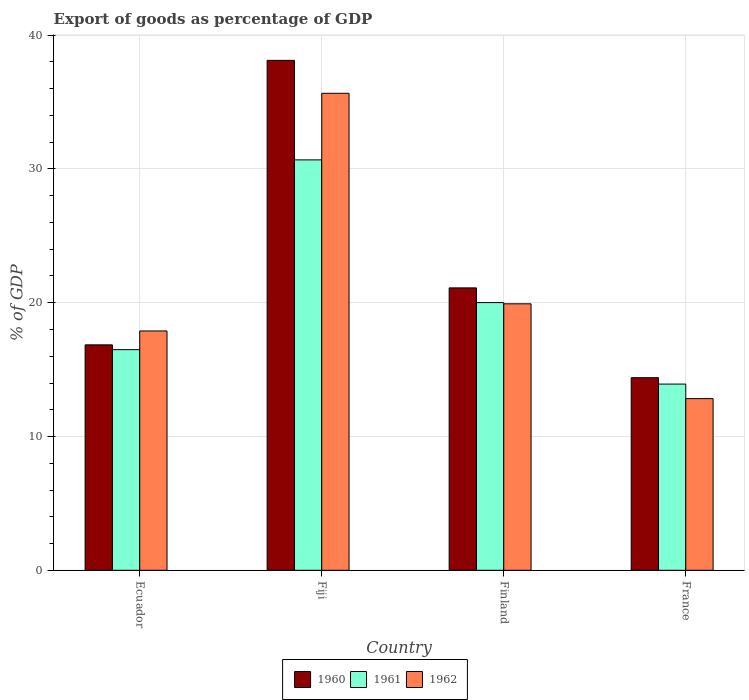How many groups of bars are there?
Offer a terse response. 4. Are the number of bars per tick equal to the number of legend labels?
Make the answer very short. Yes. Are the number of bars on each tick of the X-axis equal?
Your answer should be compact. Yes. How many bars are there on the 2nd tick from the left?
Provide a succinct answer. 3. How many bars are there on the 2nd tick from the right?
Your answer should be very brief. 3. What is the label of the 3rd group of bars from the left?
Offer a terse response. Finland. What is the export of goods as percentage of GDP in 1962 in France?
Your response must be concise. 12.83. Across all countries, what is the maximum export of goods as percentage of GDP in 1960?
Provide a short and direct response. 38.12. Across all countries, what is the minimum export of goods as percentage of GDP in 1962?
Provide a short and direct response. 12.83. In which country was the export of goods as percentage of GDP in 1962 maximum?
Your answer should be very brief. Fiji. What is the total export of goods as percentage of GDP in 1960 in the graph?
Provide a succinct answer. 90.47. What is the difference between the export of goods as percentage of GDP in 1962 in Fiji and that in Finland?
Offer a very short reply. 15.74. What is the difference between the export of goods as percentage of GDP in 1960 in Fiji and the export of goods as percentage of GDP in 1962 in Ecuador?
Ensure brevity in your answer.  20.23. What is the average export of goods as percentage of GDP in 1962 per country?
Keep it short and to the point. 21.57. What is the difference between the export of goods as percentage of GDP of/in 1960 and export of goods as percentage of GDP of/in 1962 in France?
Offer a very short reply. 1.56. In how many countries, is the export of goods as percentage of GDP in 1961 greater than 16 %?
Your response must be concise. 3. What is the ratio of the export of goods as percentage of GDP in 1961 in Fiji to that in Finland?
Make the answer very short. 1.53. Is the export of goods as percentage of GDP in 1960 in Ecuador less than that in Finland?
Give a very brief answer. Yes. Is the difference between the export of goods as percentage of GDP in 1960 in Ecuador and Fiji greater than the difference between the export of goods as percentage of GDP in 1962 in Ecuador and Fiji?
Provide a short and direct response. No. What is the difference between the highest and the second highest export of goods as percentage of GDP in 1961?
Your answer should be compact. -3.52. What is the difference between the highest and the lowest export of goods as percentage of GDP in 1961?
Provide a succinct answer. 16.76. What does the 2nd bar from the right in France represents?
Offer a terse response. 1961. Is it the case that in every country, the sum of the export of goods as percentage of GDP in 1960 and export of goods as percentage of GDP in 1961 is greater than the export of goods as percentage of GDP in 1962?
Offer a very short reply. Yes. Are all the bars in the graph horizontal?
Provide a succinct answer. No. How many countries are there in the graph?
Offer a terse response. 4. Does the graph contain grids?
Provide a succinct answer. Yes. Where does the legend appear in the graph?
Offer a very short reply. Bottom center. How many legend labels are there?
Provide a short and direct response. 3. What is the title of the graph?
Ensure brevity in your answer.  Export of goods as percentage of GDP. Does "1995" appear as one of the legend labels in the graph?
Keep it short and to the point. No. What is the label or title of the Y-axis?
Provide a succinct answer. % of GDP. What is the % of GDP in 1960 in Ecuador?
Offer a terse response. 16.85. What is the % of GDP of 1961 in Ecuador?
Give a very brief answer. 16.49. What is the % of GDP in 1962 in Ecuador?
Your answer should be compact. 17.89. What is the % of GDP in 1960 in Fiji?
Your answer should be compact. 38.12. What is the % of GDP of 1961 in Fiji?
Your answer should be compact. 30.68. What is the % of GDP in 1962 in Fiji?
Give a very brief answer. 35.66. What is the % of GDP of 1960 in Finland?
Give a very brief answer. 21.11. What is the % of GDP in 1961 in Finland?
Keep it short and to the point. 20.01. What is the % of GDP of 1962 in Finland?
Your answer should be compact. 19.92. What is the % of GDP of 1960 in France?
Your answer should be compact. 14.4. What is the % of GDP of 1961 in France?
Your answer should be very brief. 13.92. What is the % of GDP of 1962 in France?
Your answer should be compact. 12.83. Across all countries, what is the maximum % of GDP of 1960?
Provide a succinct answer. 38.12. Across all countries, what is the maximum % of GDP of 1961?
Ensure brevity in your answer.  30.68. Across all countries, what is the maximum % of GDP in 1962?
Keep it short and to the point. 35.66. Across all countries, what is the minimum % of GDP of 1960?
Make the answer very short. 14.4. Across all countries, what is the minimum % of GDP in 1961?
Your answer should be compact. 13.92. Across all countries, what is the minimum % of GDP in 1962?
Make the answer very short. 12.83. What is the total % of GDP in 1960 in the graph?
Offer a terse response. 90.47. What is the total % of GDP in 1961 in the graph?
Keep it short and to the point. 81.1. What is the total % of GDP in 1962 in the graph?
Your answer should be compact. 86.3. What is the difference between the % of GDP in 1960 in Ecuador and that in Fiji?
Offer a very short reply. -21.26. What is the difference between the % of GDP of 1961 in Ecuador and that in Fiji?
Offer a terse response. -14.18. What is the difference between the % of GDP in 1962 in Ecuador and that in Fiji?
Offer a very short reply. -17.77. What is the difference between the % of GDP in 1960 in Ecuador and that in Finland?
Give a very brief answer. -4.26. What is the difference between the % of GDP in 1961 in Ecuador and that in Finland?
Ensure brevity in your answer.  -3.52. What is the difference between the % of GDP in 1962 in Ecuador and that in Finland?
Your response must be concise. -2.03. What is the difference between the % of GDP of 1960 in Ecuador and that in France?
Ensure brevity in your answer.  2.46. What is the difference between the % of GDP of 1961 in Ecuador and that in France?
Keep it short and to the point. 2.57. What is the difference between the % of GDP in 1962 in Ecuador and that in France?
Your answer should be very brief. 5.06. What is the difference between the % of GDP of 1960 in Fiji and that in Finland?
Give a very brief answer. 17.01. What is the difference between the % of GDP of 1961 in Fiji and that in Finland?
Ensure brevity in your answer.  10.67. What is the difference between the % of GDP of 1962 in Fiji and that in Finland?
Keep it short and to the point. 15.74. What is the difference between the % of GDP of 1960 in Fiji and that in France?
Offer a very short reply. 23.72. What is the difference between the % of GDP in 1961 in Fiji and that in France?
Ensure brevity in your answer.  16.76. What is the difference between the % of GDP in 1962 in Fiji and that in France?
Your answer should be very brief. 22.82. What is the difference between the % of GDP of 1960 in Finland and that in France?
Offer a very short reply. 6.71. What is the difference between the % of GDP in 1961 in Finland and that in France?
Ensure brevity in your answer.  6.09. What is the difference between the % of GDP in 1962 in Finland and that in France?
Your answer should be compact. 7.09. What is the difference between the % of GDP in 1960 in Ecuador and the % of GDP in 1961 in Fiji?
Provide a short and direct response. -13.83. What is the difference between the % of GDP in 1960 in Ecuador and the % of GDP in 1962 in Fiji?
Provide a short and direct response. -18.8. What is the difference between the % of GDP of 1961 in Ecuador and the % of GDP of 1962 in Fiji?
Ensure brevity in your answer.  -19.16. What is the difference between the % of GDP of 1960 in Ecuador and the % of GDP of 1961 in Finland?
Offer a terse response. -3.16. What is the difference between the % of GDP in 1960 in Ecuador and the % of GDP in 1962 in Finland?
Give a very brief answer. -3.07. What is the difference between the % of GDP in 1961 in Ecuador and the % of GDP in 1962 in Finland?
Make the answer very short. -3.43. What is the difference between the % of GDP in 1960 in Ecuador and the % of GDP in 1961 in France?
Offer a terse response. 2.93. What is the difference between the % of GDP of 1960 in Ecuador and the % of GDP of 1962 in France?
Make the answer very short. 4.02. What is the difference between the % of GDP of 1961 in Ecuador and the % of GDP of 1962 in France?
Keep it short and to the point. 3.66. What is the difference between the % of GDP in 1960 in Fiji and the % of GDP in 1961 in Finland?
Keep it short and to the point. 18.11. What is the difference between the % of GDP in 1960 in Fiji and the % of GDP in 1962 in Finland?
Keep it short and to the point. 18.2. What is the difference between the % of GDP in 1961 in Fiji and the % of GDP in 1962 in Finland?
Offer a very short reply. 10.76. What is the difference between the % of GDP of 1960 in Fiji and the % of GDP of 1961 in France?
Provide a short and direct response. 24.2. What is the difference between the % of GDP in 1960 in Fiji and the % of GDP in 1962 in France?
Your answer should be very brief. 25.28. What is the difference between the % of GDP of 1961 in Fiji and the % of GDP of 1962 in France?
Provide a short and direct response. 17.85. What is the difference between the % of GDP of 1960 in Finland and the % of GDP of 1961 in France?
Give a very brief answer. 7.19. What is the difference between the % of GDP in 1960 in Finland and the % of GDP in 1962 in France?
Provide a succinct answer. 8.28. What is the difference between the % of GDP in 1961 in Finland and the % of GDP in 1962 in France?
Keep it short and to the point. 7.18. What is the average % of GDP of 1960 per country?
Your response must be concise. 22.62. What is the average % of GDP of 1961 per country?
Keep it short and to the point. 20.27. What is the average % of GDP in 1962 per country?
Keep it short and to the point. 21.57. What is the difference between the % of GDP of 1960 and % of GDP of 1961 in Ecuador?
Your answer should be compact. 0.36. What is the difference between the % of GDP of 1960 and % of GDP of 1962 in Ecuador?
Make the answer very short. -1.04. What is the difference between the % of GDP of 1961 and % of GDP of 1962 in Ecuador?
Offer a terse response. -1.4. What is the difference between the % of GDP in 1960 and % of GDP in 1961 in Fiji?
Give a very brief answer. 7.44. What is the difference between the % of GDP in 1960 and % of GDP in 1962 in Fiji?
Give a very brief answer. 2.46. What is the difference between the % of GDP in 1961 and % of GDP in 1962 in Fiji?
Provide a short and direct response. -4.98. What is the difference between the % of GDP in 1960 and % of GDP in 1961 in Finland?
Offer a terse response. 1.1. What is the difference between the % of GDP in 1960 and % of GDP in 1962 in Finland?
Keep it short and to the point. 1.19. What is the difference between the % of GDP of 1961 and % of GDP of 1962 in Finland?
Ensure brevity in your answer.  0.09. What is the difference between the % of GDP in 1960 and % of GDP in 1961 in France?
Offer a very short reply. 0.48. What is the difference between the % of GDP in 1960 and % of GDP in 1962 in France?
Offer a terse response. 1.56. What is the difference between the % of GDP of 1961 and % of GDP of 1962 in France?
Your answer should be very brief. 1.09. What is the ratio of the % of GDP of 1960 in Ecuador to that in Fiji?
Give a very brief answer. 0.44. What is the ratio of the % of GDP in 1961 in Ecuador to that in Fiji?
Give a very brief answer. 0.54. What is the ratio of the % of GDP of 1962 in Ecuador to that in Fiji?
Ensure brevity in your answer.  0.5. What is the ratio of the % of GDP in 1960 in Ecuador to that in Finland?
Ensure brevity in your answer.  0.8. What is the ratio of the % of GDP of 1961 in Ecuador to that in Finland?
Ensure brevity in your answer.  0.82. What is the ratio of the % of GDP in 1962 in Ecuador to that in Finland?
Your answer should be very brief. 0.9. What is the ratio of the % of GDP in 1960 in Ecuador to that in France?
Provide a succinct answer. 1.17. What is the ratio of the % of GDP of 1961 in Ecuador to that in France?
Offer a very short reply. 1.18. What is the ratio of the % of GDP in 1962 in Ecuador to that in France?
Offer a terse response. 1.39. What is the ratio of the % of GDP of 1960 in Fiji to that in Finland?
Offer a terse response. 1.81. What is the ratio of the % of GDP of 1961 in Fiji to that in Finland?
Make the answer very short. 1.53. What is the ratio of the % of GDP of 1962 in Fiji to that in Finland?
Your response must be concise. 1.79. What is the ratio of the % of GDP in 1960 in Fiji to that in France?
Your answer should be compact. 2.65. What is the ratio of the % of GDP of 1961 in Fiji to that in France?
Your answer should be compact. 2.2. What is the ratio of the % of GDP of 1962 in Fiji to that in France?
Your response must be concise. 2.78. What is the ratio of the % of GDP in 1960 in Finland to that in France?
Your answer should be compact. 1.47. What is the ratio of the % of GDP in 1961 in Finland to that in France?
Keep it short and to the point. 1.44. What is the ratio of the % of GDP of 1962 in Finland to that in France?
Offer a very short reply. 1.55. What is the difference between the highest and the second highest % of GDP in 1960?
Offer a terse response. 17.01. What is the difference between the highest and the second highest % of GDP in 1961?
Your response must be concise. 10.67. What is the difference between the highest and the second highest % of GDP of 1962?
Make the answer very short. 15.74. What is the difference between the highest and the lowest % of GDP of 1960?
Your response must be concise. 23.72. What is the difference between the highest and the lowest % of GDP of 1961?
Offer a terse response. 16.76. What is the difference between the highest and the lowest % of GDP in 1962?
Make the answer very short. 22.82. 